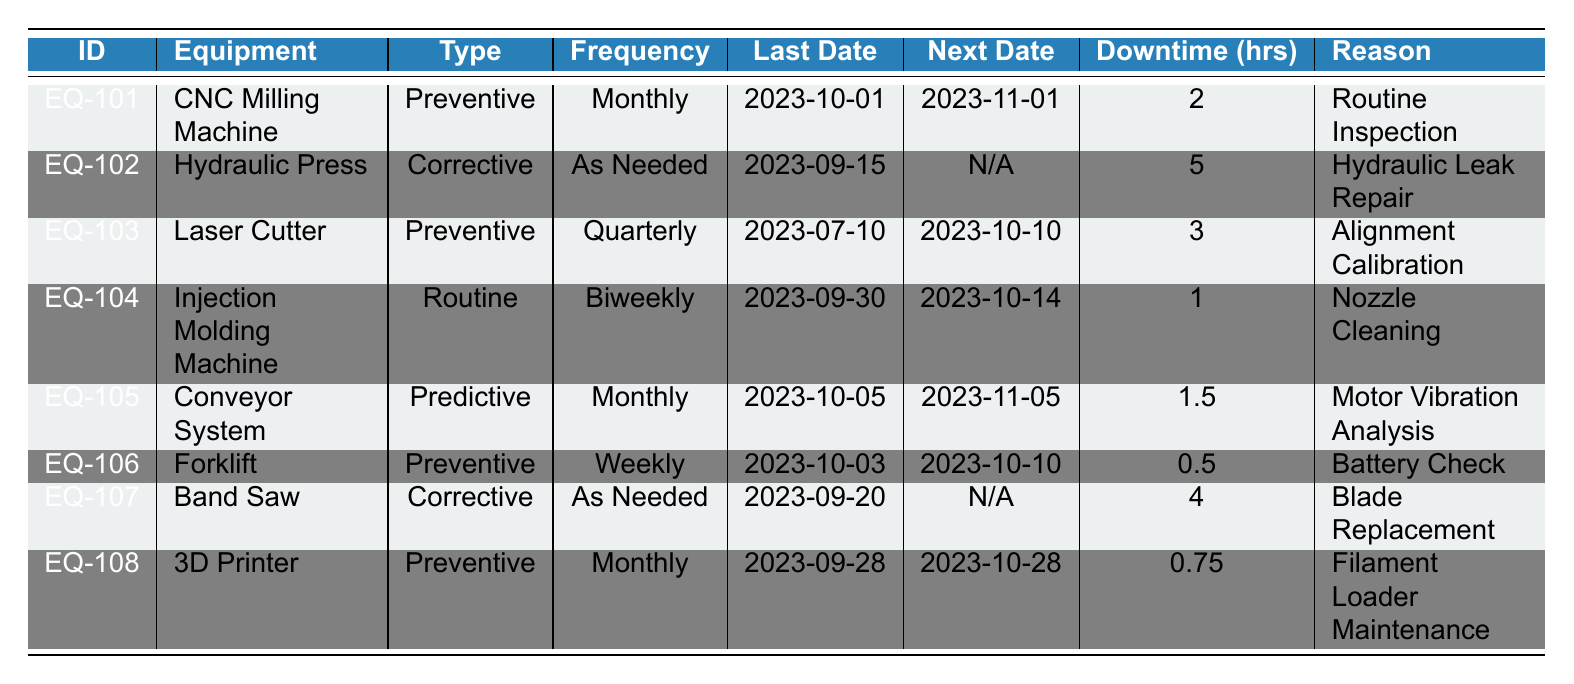What is the next due date for the CNC Milling Machine? The next due date is listed in the corresponding row under the "Next Date" column. For the CNC Milling Machine, it is shown as 2023-11-01.
Answer: 2023-11-01 How many hours of downtime were recorded for the Hydraulic Press? The downtime hours for the Hydraulic Press are provided in the "Downtime (hrs)" column. It states 5 hours for this equipment.
Answer: 5 Is the Laser Cutter scheduled for maintenance next month? The next due date for the Laser Cutter is listed as 2023-10-10. Since the date falls within next month (November), yes, it is scheduled for maintenance next month.
Answer: Yes What maintenance type does the Forklift require? The maintenance type for the Forklift is specified in the "Type" column, which indicates it requires Preventive maintenance.
Answer: Preventive What is the total downtime for all preventive maintenance equipment? To find the total downtime for all preventive maintenance equipment, we look for entries that specify "Preventive" maintenance type and sum their downtime hours: 2 (CNC Milling Machine) + 3 (Laser Cutter) + 0.5 (Forklift) + 0.75 (3D Printer) = 6.25 total downtime hours.
Answer: 6.25 Is there any equipment with a monthly maintenance frequency that has downtime less than 2 hours? The only equipment with a monthly maintenance frequency and downtime less than 2 hours is the 3D Printer which shows 0.75 hours of downtime. Thus, the answer is yes.
Answer: Yes How many different types of maintenance are listed in the table? The maintenance types listed are Preventive, Corrective, Routine, and Predictive. Thus, counting these unique types gives us a total of 4 different types of maintenance.
Answer: 4 Which equipment has the longest downtime and what is the reason? To find the equipment with the longest downtime, we compare the downtime hours: the Hydraulic Press has 5 hours of downtime, which is the highest in the table. The reason is listed as "Hydraulic Leak Repair."
Answer: Hydraulic Press; Hydraulic Leak Repair How many pieces of equipment are due for maintenance in the next two weeks? Today’s date is 2023-10-03. The next two weeks ends on 2023-10-17. The equipment due for maintenance within this timeframe are the Injection Molding Machine (next due 2023-10-14) and the Forklift (next due 2023-10-10), totaling 2 pieces of equipment.
Answer: 2 